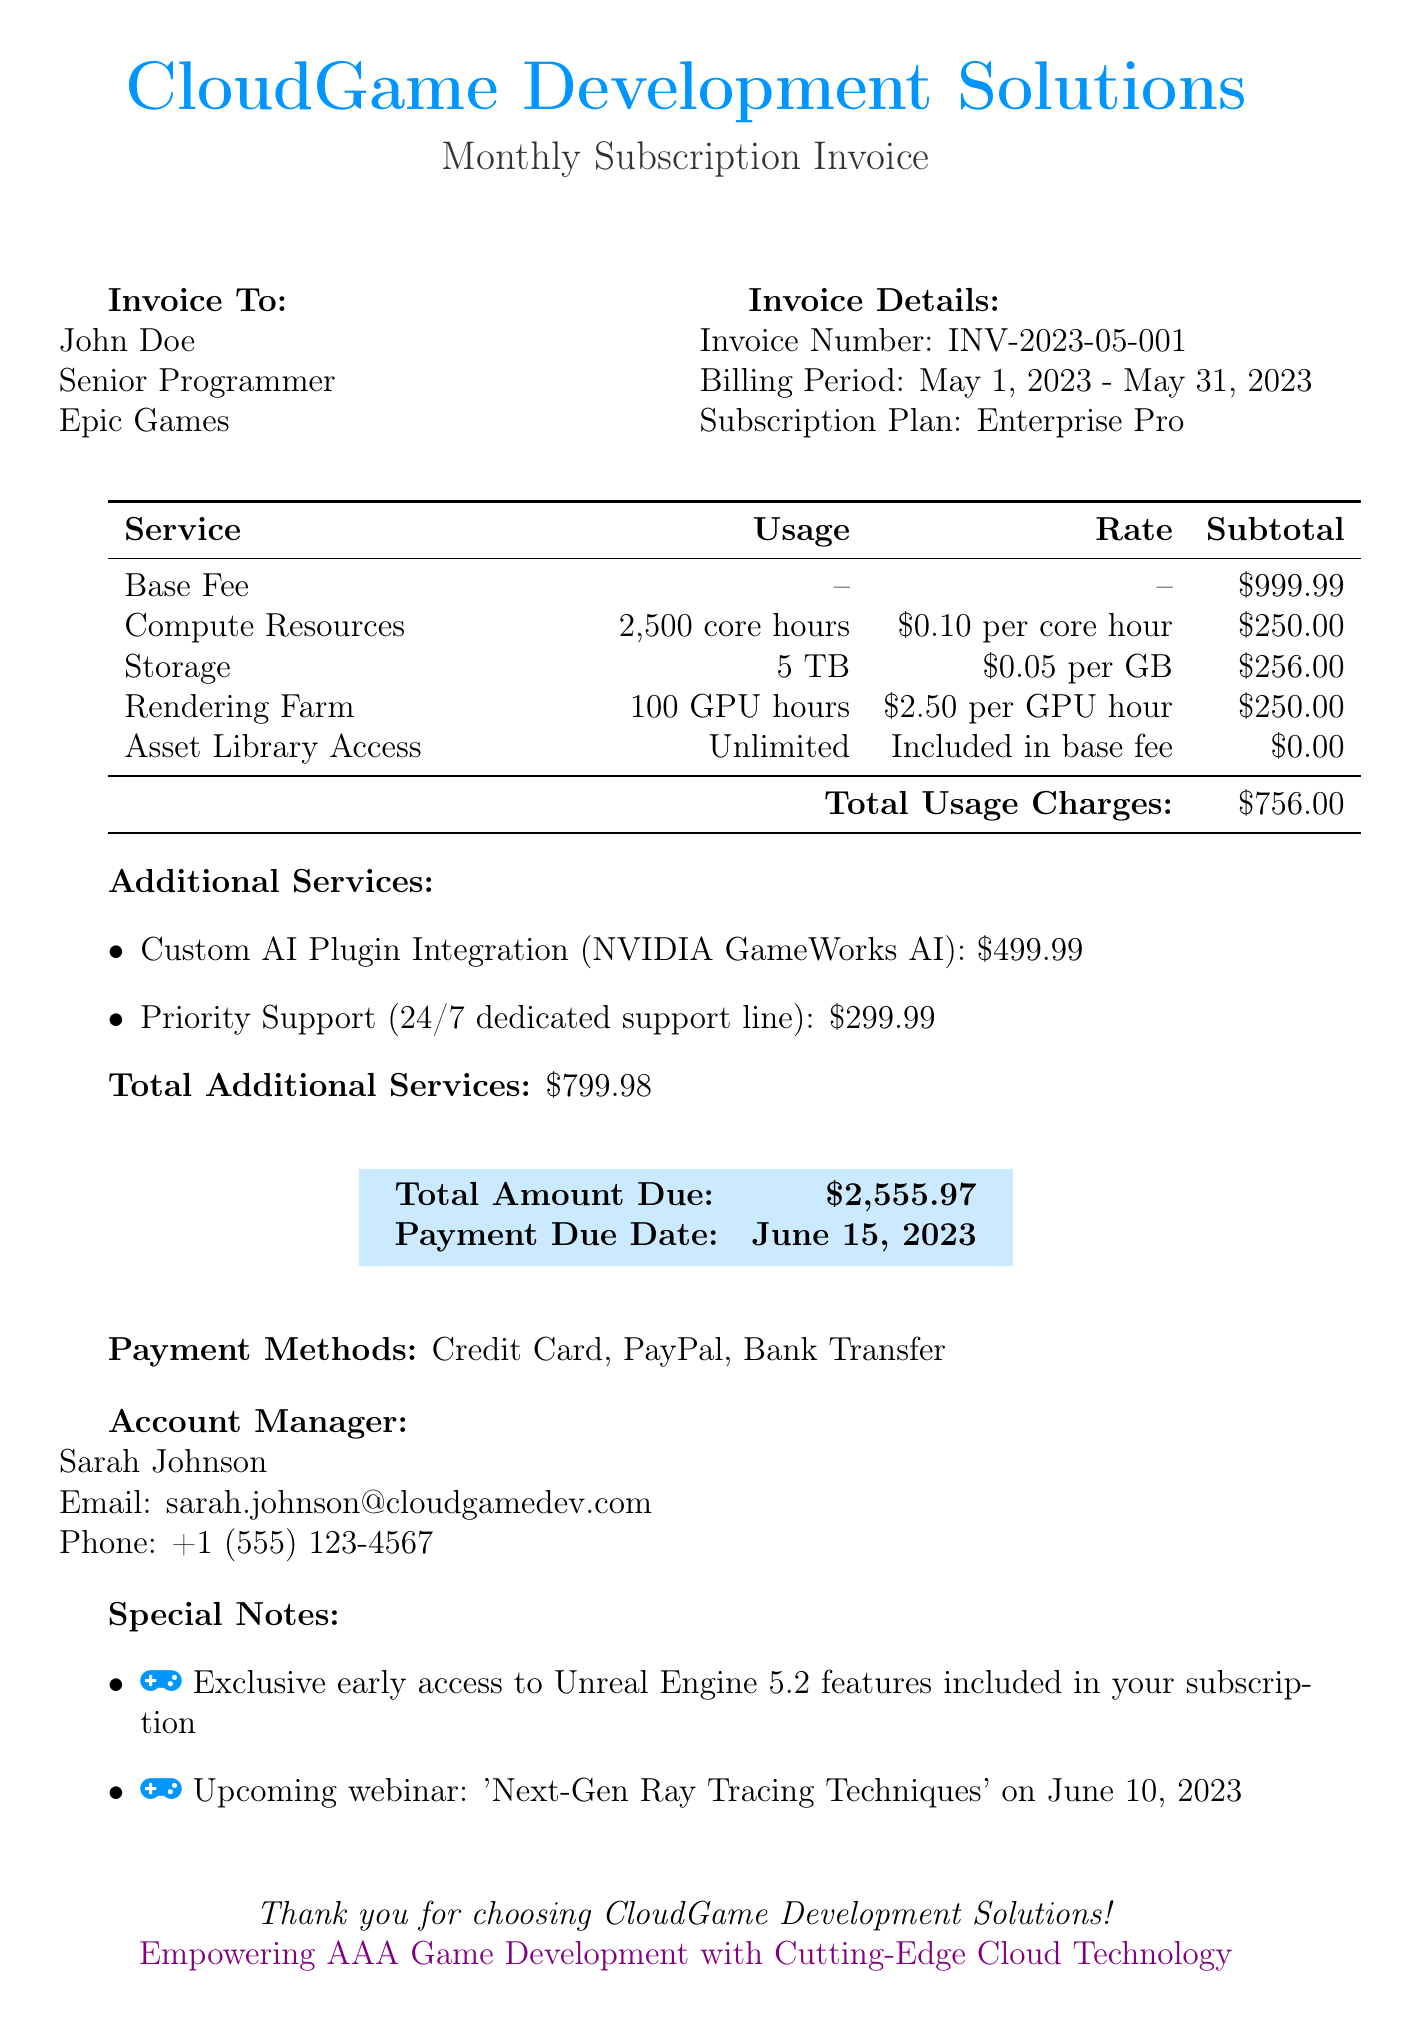What is the total amount due? The total amount due is stated clearly in the document as the final amount that needs to be paid.
Answer: $2,555.97 Who is the account manager? The account manager's name is listed at the end of the document, providing direct contact for any inquiries.
Answer: Sarah Johnson What is the base fee for the subscription plan? The base fee is a part of the charges presented under subscription fees in the document.
Answer: $999.99 How many GPU hours were used? The document specifies the usage of GPU hours for the Rendering Farm service, indicating the amount utilized.
Answer: 100 GPU hours When is the payment due date? The payment due date is explicitly stated at the bottom of the invoice under the payment details section.
Answer: June 15, 2023 What is the total for additional services? The total for additional services is the sum of all costs related to services added to the main subscription.
Answer: $799.98 What service received unlimited access? The document lists services along with their respective usage and charges, with one specifically mentioned as unlimited.
Answer: Asset Library Access What is the rate for Compute Resources? The rate for Compute Resources is presented in the usage breakdown section of the document.
Answer: $0.10 per core hour What special feature is included in the subscription? The special notes section highlights unique benefits associated with the subscription plan.
Answer: Exclusive early access to Unreal Engine 5.2 features 